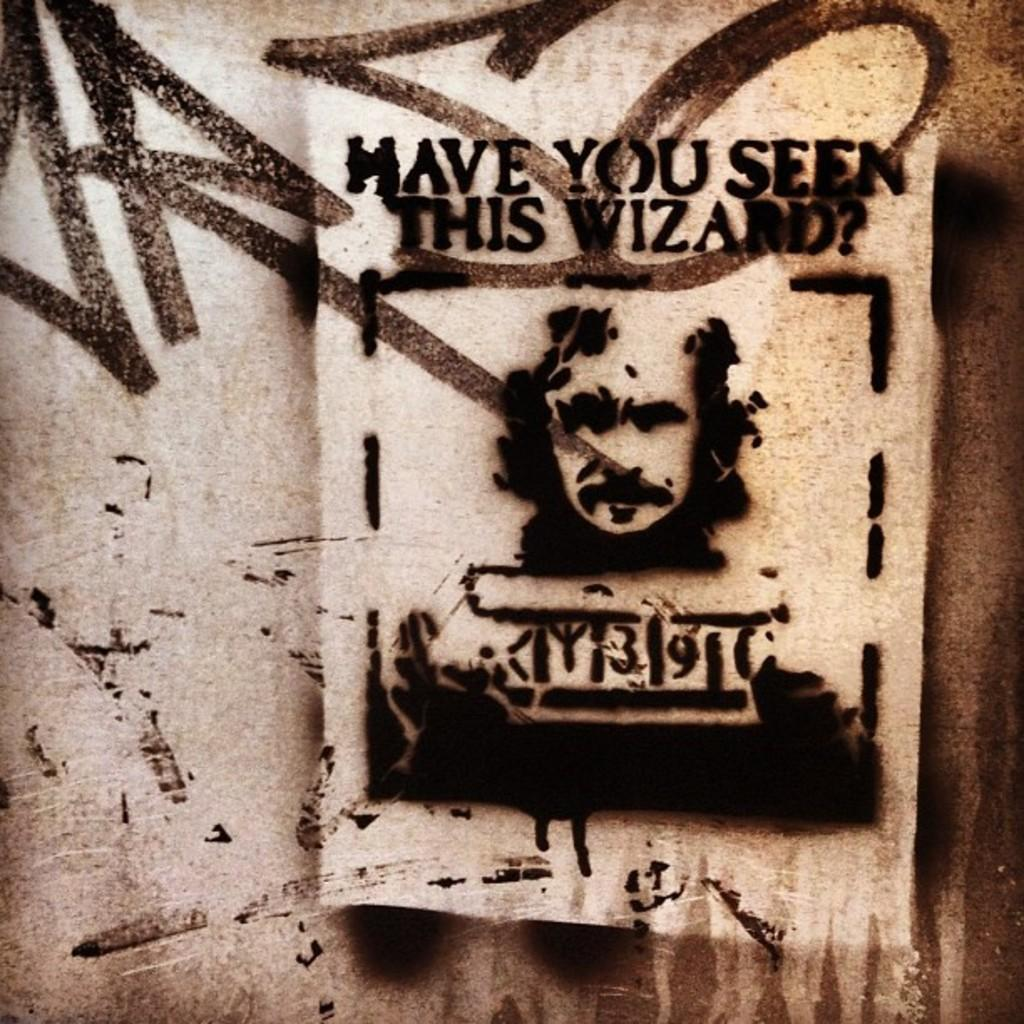What is featured on the poster in the image? The poster is of a person. Where is the poster located in the image? The poster is on a wall. What type of tooth is visible in the image? There is no tooth present in the image. Is the person on the poster being attacked by someone or something in the image? There is no indication of an attack in the image; it only features a poster of a person on a wall. 